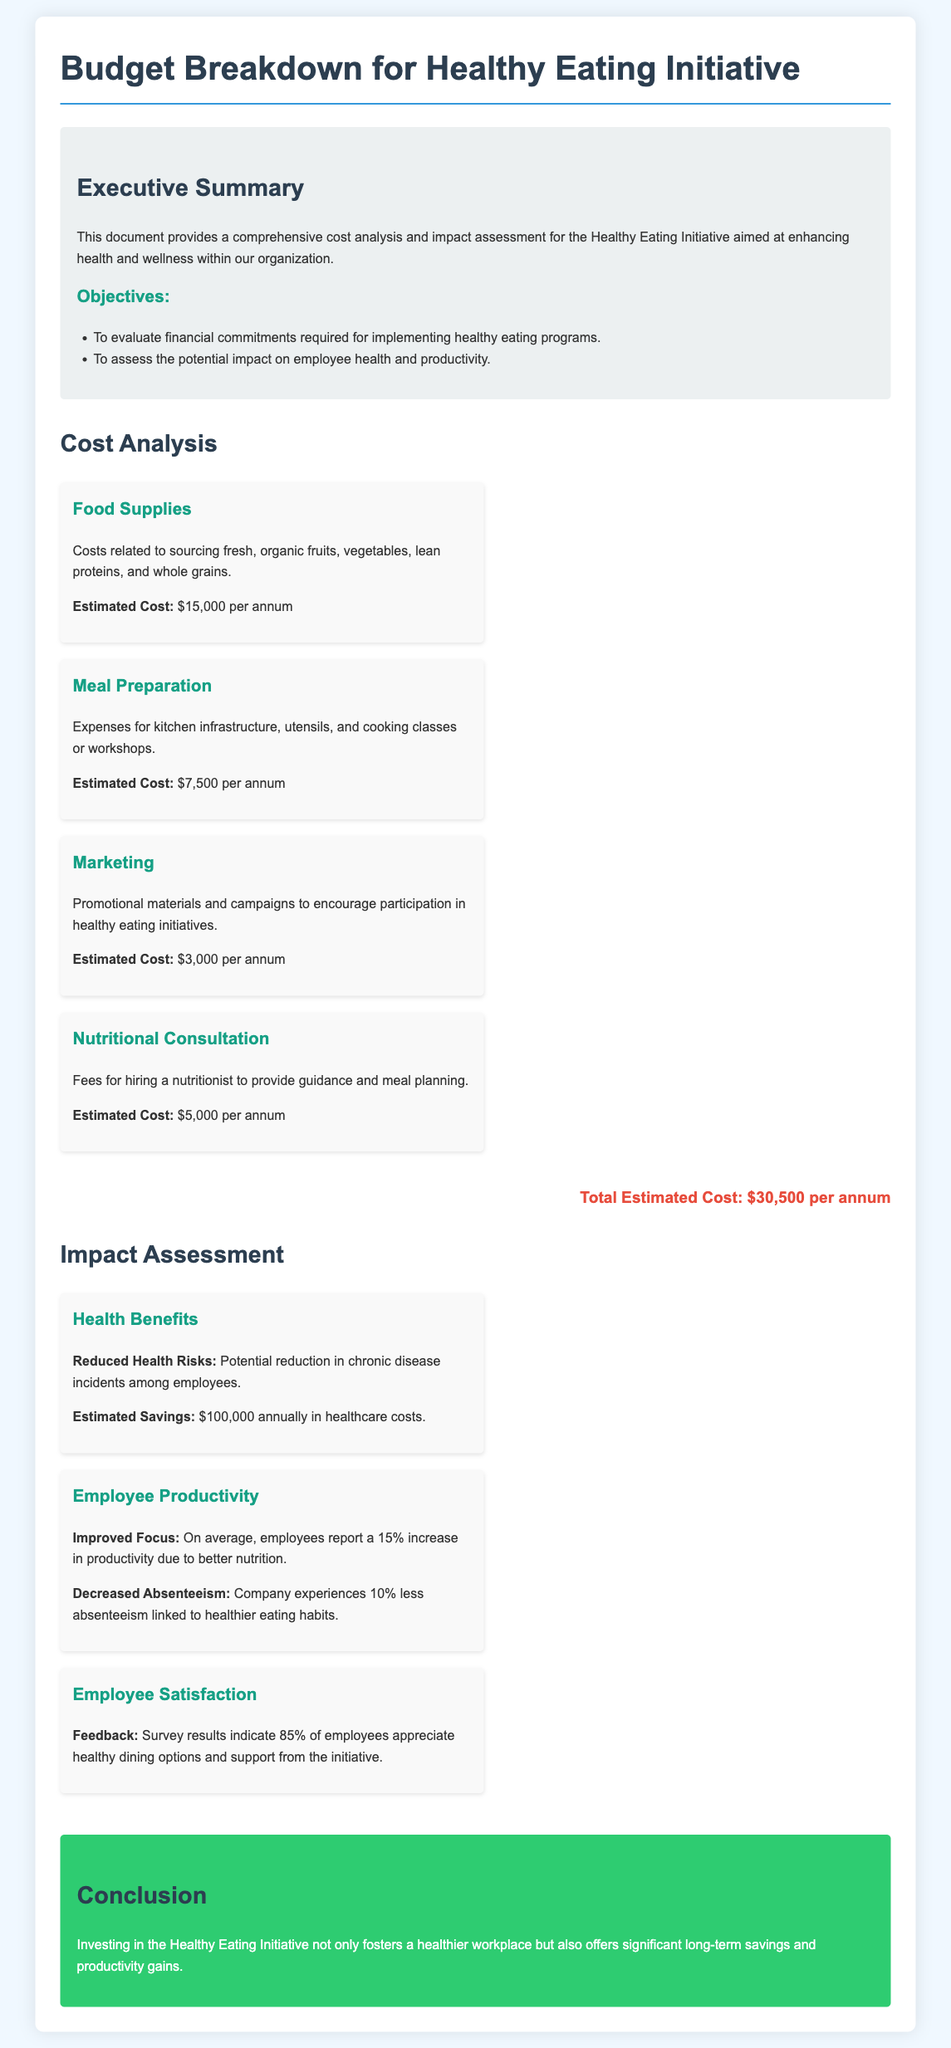What is the total estimated cost of the initiative? The total estimated cost is listed at the end of the Cost Analysis section: $30,500 per annum.
Answer: $30,500 per annum What is the estimated cost for food supplies? The specific cost for food supplies is provided in the Cost Analysis section, which states $15,000 per annum.
Answer: $15,000 per annum What percentage increase in productivity do employees report on average? The document states that employees report a 15% increase in productivity due to better nutrition.
Answer: 15% How much can be saved annually in healthcare costs due to the initiative? The potential savings are mentioned under Health Benefits as $100,000 annually.
Answer: $100,000 What is one objective of the Healthy Eating Initiative? The objectives are outlined in the Executive Summary, one being to evaluate financial commitments.
Answer: Evaluate financial commitments How much is allocated for marketing? The Cost Analysis section reveals that the estimated cost for marketing is $3,000 per annum.
Answer: $3,000 per annum What percentage of employees support healthy dining options? According to the Employee Satisfaction impact item, survey results indicate that 85% of employees appreciate the options.
Answer: 85% What type of counseling is included in the costs? The initiative includes fees for nutritional consultation, as listed in the Cost Analysis section.
Answer: Nutritional consultation What are the two aspects of employee productivity mentioned in the impact assessment? The impact assessment outlines improved focus and decreased absenteeism as aspects of productivity.
Answer: Improved focus and decreased absenteeism 